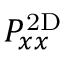<formula> <loc_0><loc_0><loc_500><loc_500>P _ { x x } ^ { 2 D }</formula> 